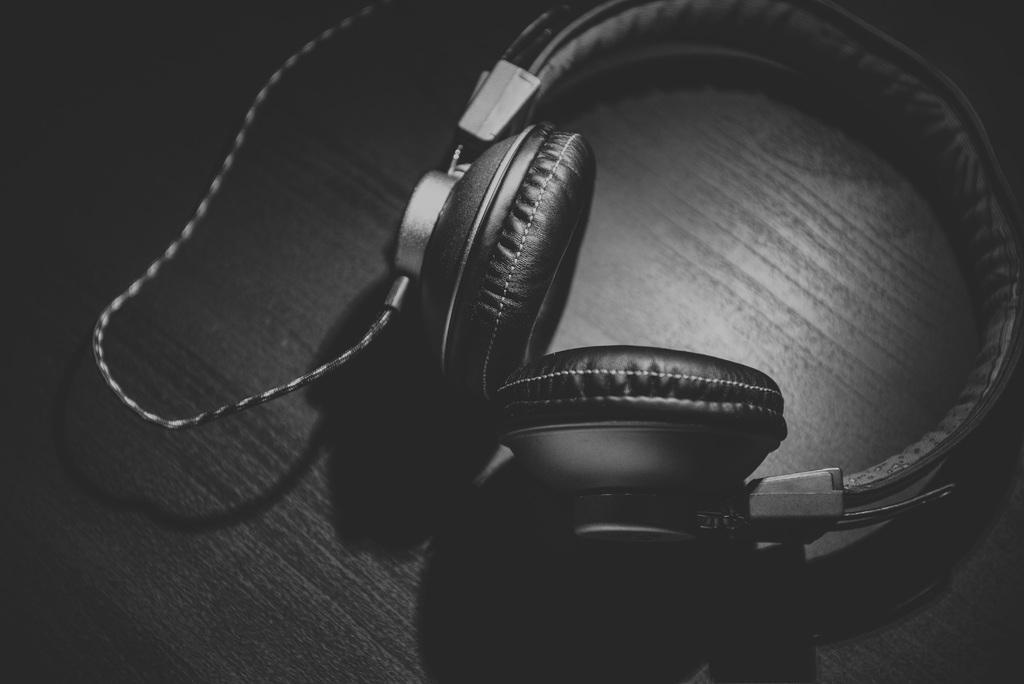Describe this image in one or two sentences. In this picture we can see a headphone on the table. 